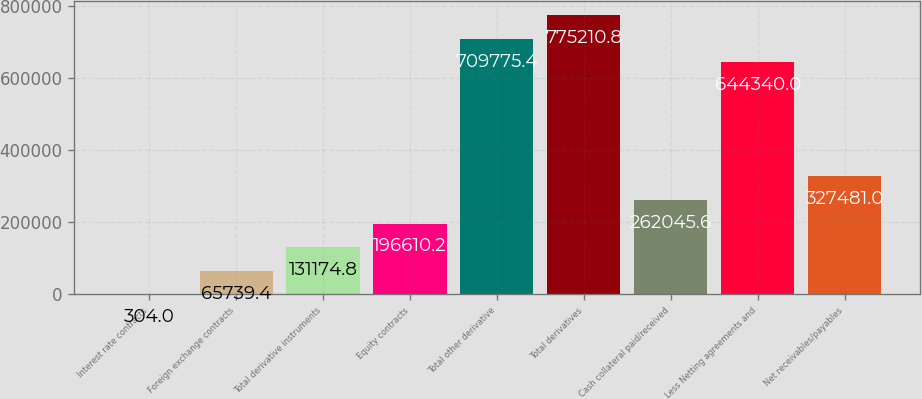Convert chart to OTSL. <chart><loc_0><loc_0><loc_500><loc_500><bar_chart><fcel>Interest rate contracts<fcel>Foreign exchange contracts<fcel>Total derivative instruments<fcel>Equity contracts<fcel>Total other derivative<fcel>Total derivatives<fcel>Cash collateral paid/received<fcel>Less Netting agreements and<fcel>Net receivables/payables<nl><fcel>304<fcel>65739.4<fcel>131175<fcel>196610<fcel>709775<fcel>775211<fcel>262046<fcel>644340<fcel>327481<nl></chart> 